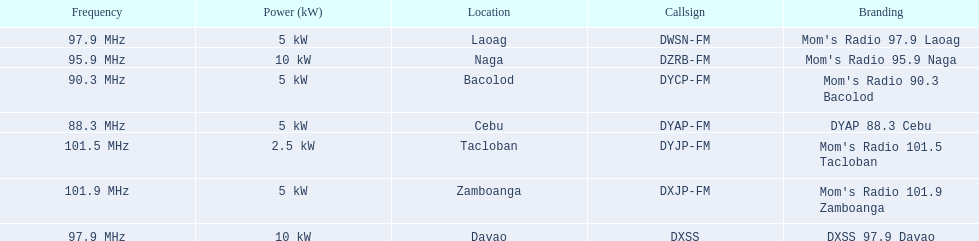What are the total number of radio stations on this list? 7. 